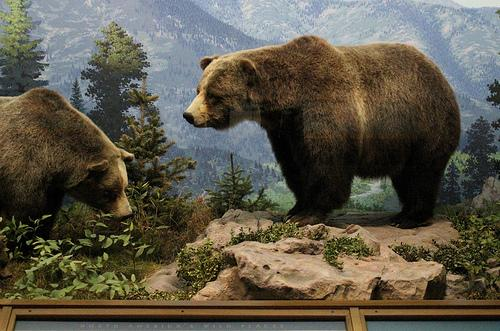Write a poetic depiction of the scene captured in the image. In nature's embrace, two brown bears dwell; amidst rocks, trees and mountain realms, flora and fauna bid them a warm farewell. Write a haiku inspired by the visual elements in the image. (Haiku format: 5 syllables, 7 syllables, 5 syllables)  Harmony prevails. Using vivid adjectives, describe the scene of the image. Majestic mountains oversee the harmonious meeting of two magnificent bears, surrounded by lush foliage and rugged rocks. Provide a brief and simple description of the main action occurring in the image. Two bears are standing on rocks with mountains and trees in the background. Elaborate on the key distinguishing feature of the primary animal in the image. The big brown bear on the right has a black nose and is standing on a rock formation. Describe the colors and size of the primary focal points in the image. A large brown bear dominates the right side of the frame, while a smaller bear rests in the left corner with a backdrop of towering green pines and misty mountains. Mention the dominant animal present in the image and its main action. The big brown bear on the right is standing on four legs on a rocky terrain. Create a short story based on the image description. Amidst the foggy wilderness, a young brown bear explores a rocky hillside accompanied by an older relative, searching for new adventures. Describe the location where the two bears are situated and the background elements. Two grizzly bears foraging in the woods with mountains, pine trees, and shrubs in the background. Talk about a specific weather-related aspect in the image. Foggy looking mountains make a dramatic, atmospheric background for the scene with the bears. 